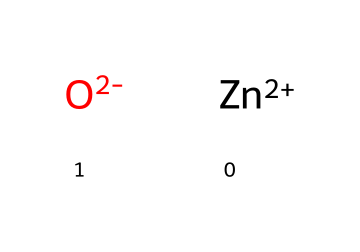How many atoms are present in this chemical structure? The chemical structure consists of two zinc atoms and two oxygen atoms. Therefore, the total count is four atoms.
Answer: four atoms What is the oxidation state of zinc in this compound? Zinc in this structure has a +2 oxidation state as indicated by the charge notation [Zn+2].
Answer: +2 What type of bonding is present in zinc oxide? The structure suggests ionic bonding as zinc is a metal with a positive charge while oxygen is a non-metal with a negative charge, indicating transfer of electrons.
Answer: ionic What role does zinc oxide play in sunscreen formulations? Zinc oxide acts as a physical UV filter, reflecting and scattering UV radiation to protect the skin from sun damage.
Answer: UV filter What is the charge on the oxygen in this chemical structure? The oxygen atom carries a -2 charge, as indicated by the notation [O-2].
Answer: -2 What is the primary use of zinc oxide in cosmetics? Zinc oxide is primarily used for its sun protection properties in cosmetic formulations, specifically in sunscreens.
Answer: sun protection 